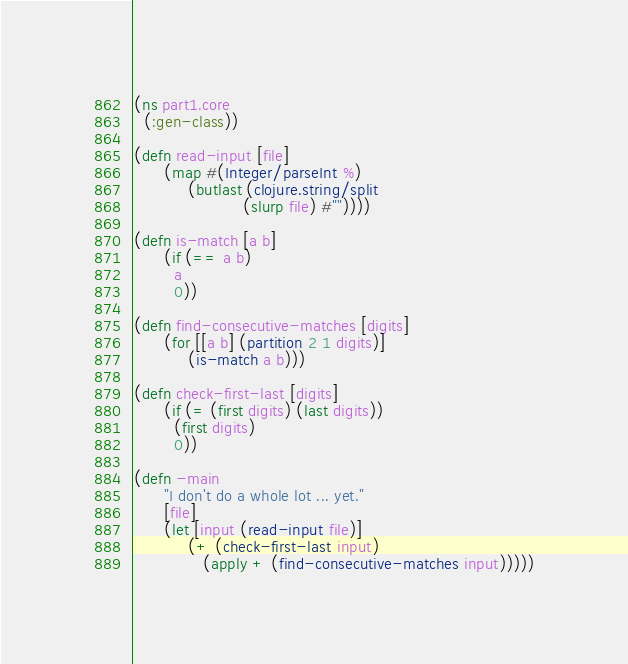Convert code to text. <code><loc_0><loc_0><loc_500><loc_500><_Clojure_>(ns part1.core
  (:gen-class))

(defn read-input [file]
      (map #(Integer/parseInt %)
           (butlast (clojure.string/split
                      (slurp file) #""))))

(defn is-match [a b]
      (if (== a b)
        a
        0))

(defn find-consecutive-matches [digits]
      (for [[a b] (partition 2 1 digits)]
           (is-match a b)))

(defn check-first-last [digits]
      (if (= (first digits) (last digits))
        (first digits)
        0))

(defn -main
      "I don't do a whole lot ... yet."
      [file]
      (let [input (read-input file)]
           (+ (check-first-last input)
              (apply + (find-consecutive-matches input)))))
</code> 